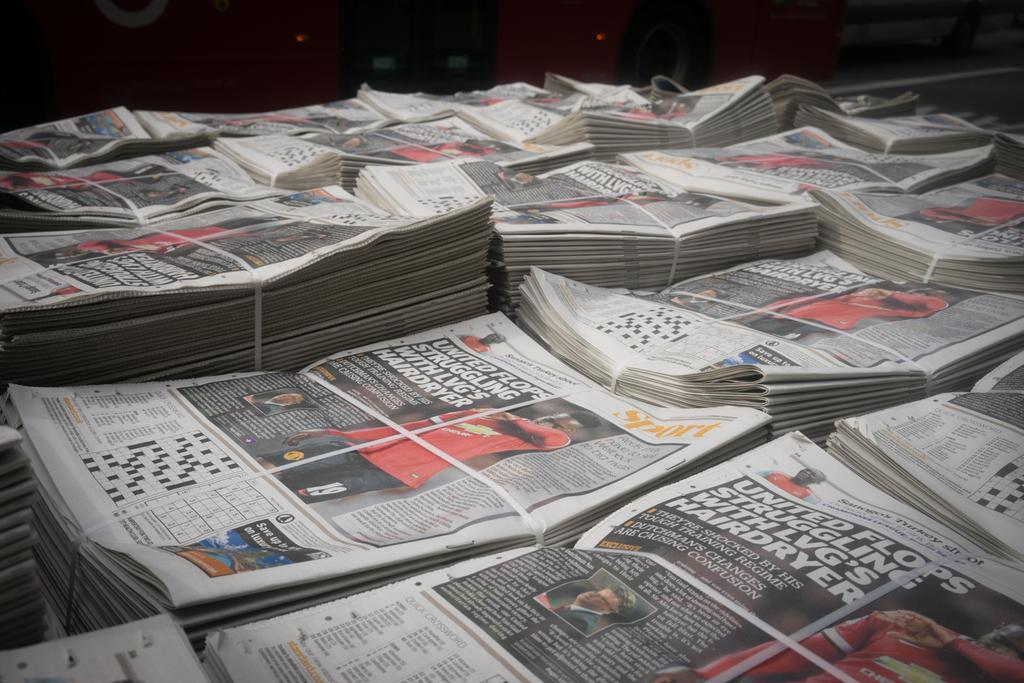<image>
Create a compact narrative representing the image presented. Stacks of newspapers displaying a story about United Football club are tied together. 